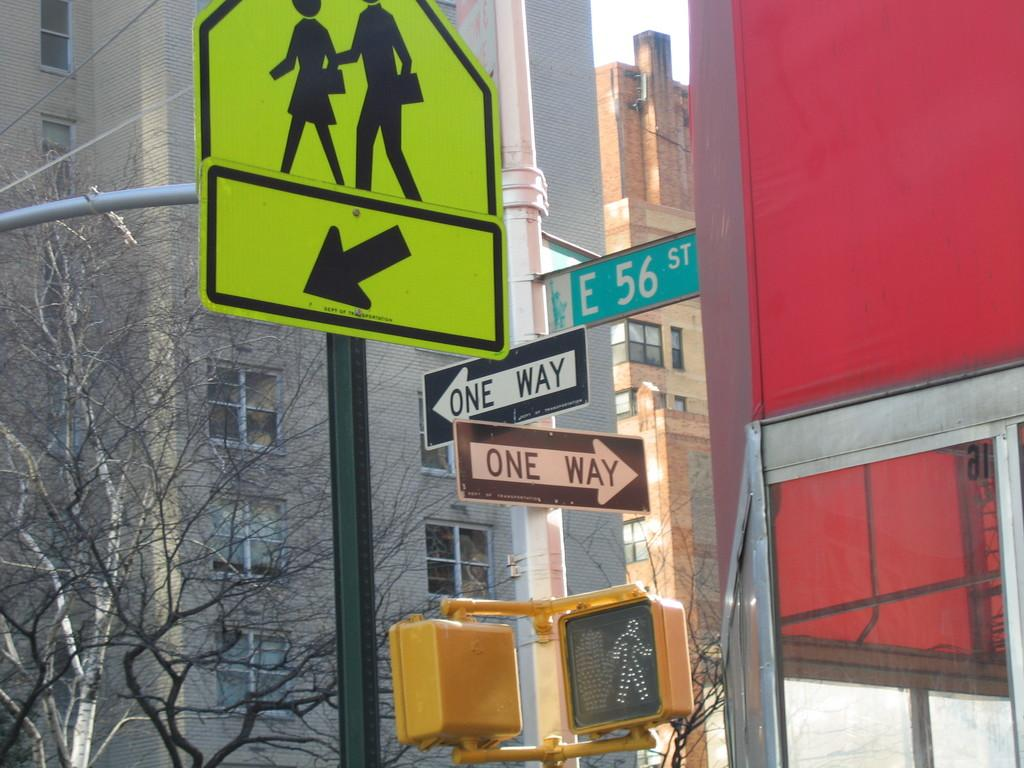<image>
Offer a succinct explanation of the picture presented. A street scene with two signs reading One Way. 